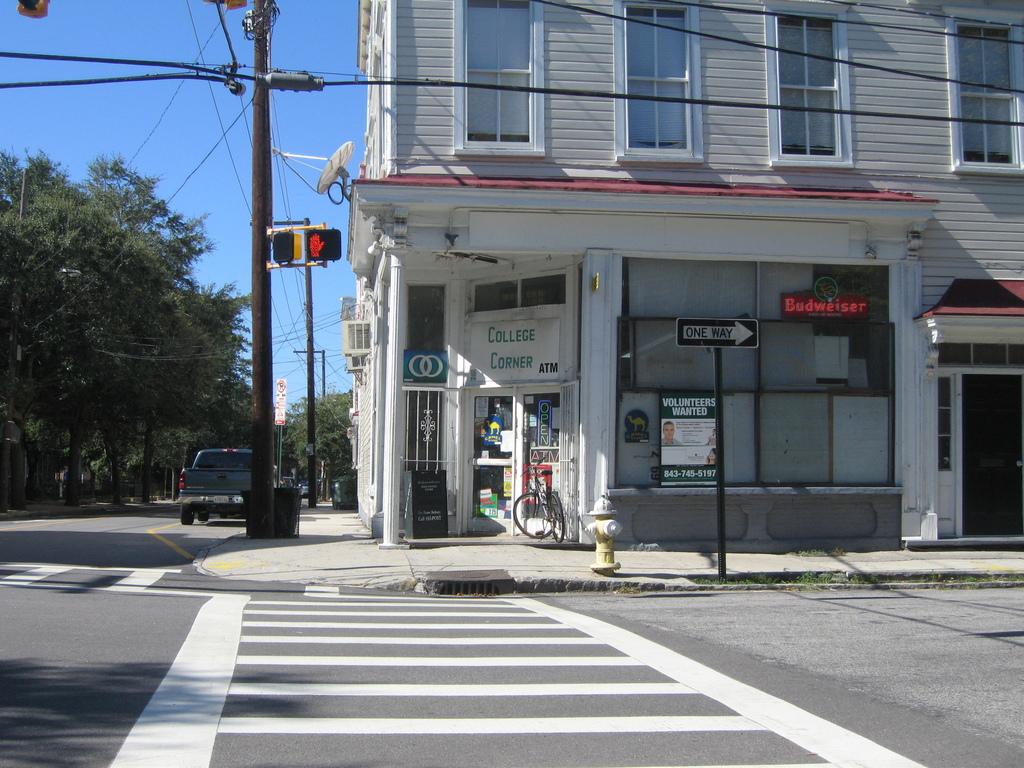The sign in the window says what is wanted?
Your response must be concise. Volunteers. The black street sign says?
Your response must be concise. One way. 